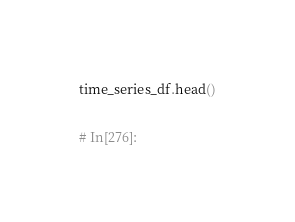<code> <loc_0><loc_0><loc_500><loc_500><_Python_>
time_series_df.head()


# In[276]:

</code> 